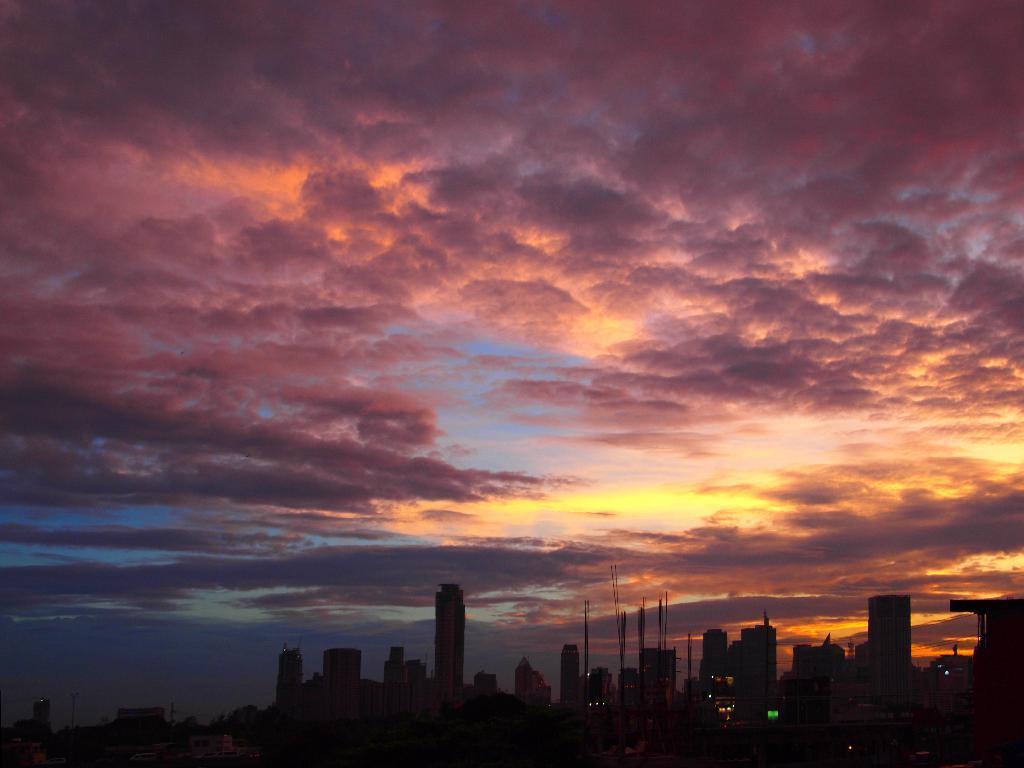How would you summarize this image in a sentence or two? As we can see in the image there is the scene of sunset where all the clouds in the sky are turned into red colour reddish yellow colour and the bottom there are lot of buildings as its a sunset the buildings and the area is getting darker. 